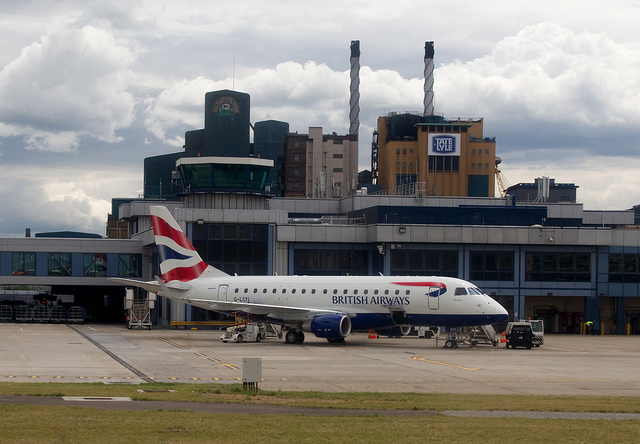Please transcribe the text in this image. BRITISH AIRWAYS LYLE 